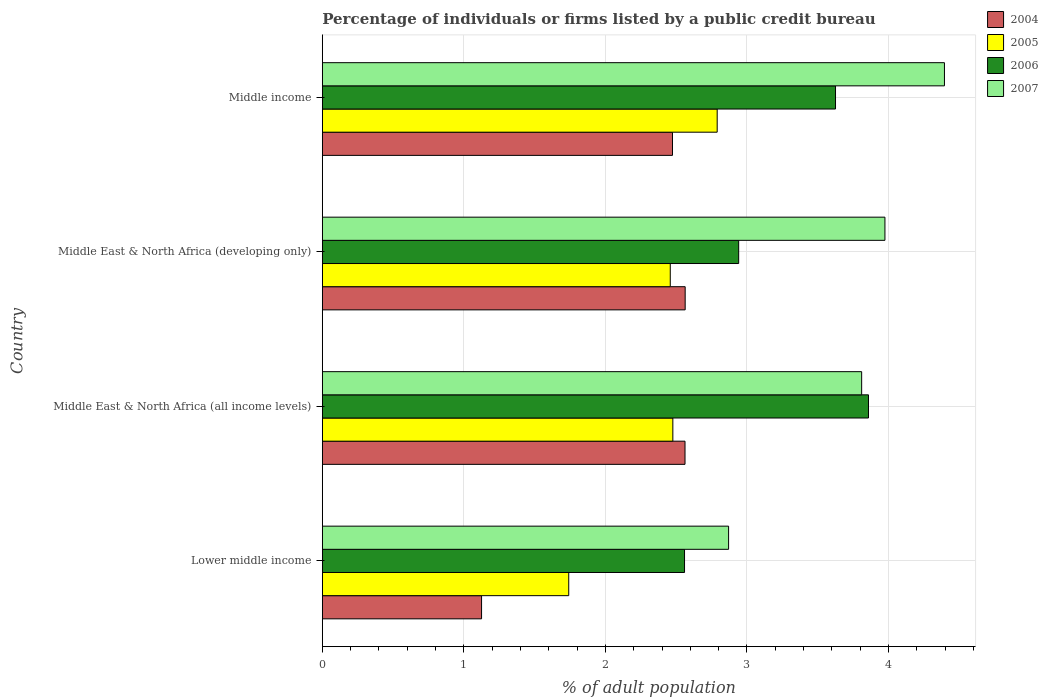How many different coloured bars are there?
Your response must be concise. 4. How many groups of bars are there?
Offer a terse response. 4. Are the number of bars per tick equal to the number of legend labels?
Offer a very short reply. Yes. How many bars are there on the 1st tick from the bottom?
Make the answer very short. 4. What is the label of the 1st group of bars from the top?
Provide a succinct answer. Middle income. What is the percentage of population listed by a public credit bureau in 2007 in Middle East & North Africa (developing only)?
Give a very brief answer. 3.98. Across all countries, what is the maximum percentage of population listed by a public credit bureau in 2007?
Offer a very short reply. 4.4. Across all countries, what is the minimum percentage of population listed by a public credit bureau in 2007?
Your response must be concise. 2.87. In which country was the percentage of population listed by a public credit bureau in 2006 maximum?
Your answer should be very brief. Middle East & North Africa (all income levels). In which country was the percentage of population listed by a public credit bureau in 2007 minimum?
Offer a very short reply. Lower middle income. What is the total percentage of population listed by a public credit bureau in 2007 in the graph?
Provide a succinct answer. 15.05. What is the difference between the percentage of population listed by a public credit bureau in 2006 in Lower middle income and that in Middle East & North Africa (developing only)?
Provide a succinct answer. -0.38. What is the difference between the percentage of population listed by a public credit bureau in 2005 in Middle East & North Africa (all income levels) and the percentage of population listed by a public credit bureau in 2006 in Middle East & North Africa (developing only)?
Provide a short and direct response. -0.47. What is the average percentage of population listed by a public credit bureau in 2006 per country?
Ensure brevity in your answer.  3.25. What is the difference between the percentage of population listed by a public credit bureau in 2007 and percentage of population listed by a public credit bureau in 2005 in Middle income?
Your response must be concise. 1.61. In how many countries, is the percentage of population listed by a public credit bureau in 2007 greater than 3.2 %?
Make the answer very short. 3. What is the ratio of the percentage of population listed by a public credit bureau in 2005 in Middle East & North Africa (all income levels) to that in Middle East & North Africa (developing only)?
Provide a short and direct response. 1.01. Is the percentage of population listed by a public credit bureau in 2006 in Middle East & North Africa (developing only) less than that in Middle income?
Ensure brevity in your answer.  Yes. What is the difference between the highest and the second highest percentage of population listed by a public credit bureau in 2004?
Provide a succinct answer. 0. What is the difference between the highest and the lowest percentage of population listed by a public credit bureau in 2007?
Provide a short and direct response. 1.53. Is the sum of the percentage of population listed by a public credit bureau in 2007 in Lower middle income and Middle East & North Africa (developing only) greater than the maximum percentage of population listed by a public credit bureau in 2005 across all countries?
Provide a succinct answer. Yes. Is it the case that in every country, the sum of the percentage of population listed by a public credit bureau in 2007 and percentage of population listed by a public credit bureau in 2004 is greater than the sum of percentage of population listed by a public credit bureau in 2006 and percentage of population listed by a public credit bureau in 2005?
Your response must be concise. No. How many bars are there?
Your answer should be compact. 16. Are all the bars in the graph horizontal?
Make the answer very short. Yes. How many countries are there in the graph?
Offer a terse response. 4. What is the difference between two consecutive major ticks on the X-axis?
Keep it short and to the point. 1. Are the values on the major ticks of X-axis written in scientific E-notation?
Ensure brevity in your answer.  No. Does the graph contain any zero values?
Your answer should be compact. No. Where does the legend appear in the graph?
Your answer should be very brief. Top right. How are the legend labels stacked?
Offer a terse response. Vertical. What is the title of the graph?
Keep it short and to the point. Percentage of individuals or firms listed by a public credit bureau. What is the label or title of the X-axis?
Your response must be concise. % of adult population. What is the label or title of the Y-axis?
Provide a succinct answer. Country. What is the % of adult population of 2005 in Lower middle income?
Keep it short and to the point. 1.74. What is the % of adult population of 2006 in Lower middle income?
Ensure brevity in your answer.  2.56. What is the % of adult population of 2007 in Lower middle income?
Your answer should be compact. 2.87. What is the % of adult population of 2004 in Middle East & North Africa (all income levels)?
Provide a succinct answer. 2.56. What is the % of adult population in 2005 in Middle East & North Africa (all income levels)?
Offer a very short reply. 2.48. What is the % of adult population in 2006 in Middle East & North Africa (all income levels)?
Your answer should be compact. 3.86. What is the % of adult population of 2007 in Middle East & North Africa (all income levels)?
Your answer should be very brief. 3.81. What is the % of adult population of 2004 in Middle East & North Africa (developing only)?
Your answer should be very brief. 2.56. What is the % of adult population in 2005 in Middle East & North Africa (developing only)?
Your answer should be very brief. 2.46. What is the % of adult population of 2006 in Middle East & North Africa (developing only)?
Provide a short and direct response. 2.94. What is the % of adult population of 2007 in Middle East & North Africa (developing only)?
Offer a terse response. 3.98. What is the % of adult population of 2004 in Middle income?
Provide a succinct answer. 2.47. What is the % of adult population in 2005 in Middle income?
Offer a very short reply. 2.79. What is the % of adult population of 2006 in Middle income?
Provide a succinct answer. 3.63. What is the % of adult population of 2007 in Middle income?
Ensure brevity in your answer.  4.4. Across all countries, what is the maximum % of adult population of 2004?
Your answer should be compact. 2.56. Across all countries, what is the maximum % of adult population in 2005?
Ensure brevity in your answer.  2.79. Across all countries, what is the maximum % of adult population of 2006?
Your answer should be compact. 3.86. Across all countries, what is the maximum % of adult population of 2007?
Provide a short and direct response. 4.4. Across all countries, what is the minimum % of adult population of 2005?
Offer a terse response. 1.74. Across all countries, what is the minimum % of adult population in 2006?
Offer a very short reply. 2.56. Across all countries, what is the minimum % of adult population in 2007?
Offer a very short reply. 2.87. What is the total % of adult population in 2004 in the graph?
Ensure brevity in your answer.  8.73. What is the total % of adult population in 2005 in the graph?
Your answer should be compact. 9.47. What is the total % of adult population in 2006 in the graph?
Your answer should be compact. 12.99. What is the total % of adult population of 2007 in the graph?
Your response must be concise. 15.05. What is the difference between the % of adult population in 2004 in Lower middle income and that in Middle East & North Africa (all income levels)?
Your response must be concise. -1.44. What is the difference between the % of adult population of 2005 in Lower middle income and that in Middle East & North Africa (all income levels)?
Ensure brevity in your answer.  -0.74. What is the difference between the % of adult population of 2006 in Lower middle income and that in Middle East & North Africa (all income levels)?
Provide a succinct answer. -1.3. What is the difference between the % of adult population of 2007 in Lower middle income and that in Middle East & North Africa (all income levels)?
Give a very brief answer. -0.94. What is the difference between the % of adult population of 2004 in Lower middle income and that in Middle East & North Africa (developing only)?
Your answer should be very brief. -1.44. What is the difference between the % of adult population of 2005 in Lower middle income and that in Middle East & North Africa (developing only)?
Give a very brief answer. -0.72. What is the difference between the % of adult population of 2006 in Lower middle income and that in Middle East & North Africa (developing only)?
Keep it short and to the point. -0.38. What is the difference between the % of adult population in 2007 in Lower middle income and that in Middle East & North Africa (developing only)?
Give a very brief answer. -1.1. What is the difference between the % of adult population in 2004 in Lower middle income and that in Middle income?
Provide a succinct answer. -1.35. What is the difference between the % of adult population in 2005 in Lower middle income and that in Middle income?
Your answer should be very brief. -1.05. What is the difference between the % of adult population in 2006 in Lower middle income and that in Middle income?
Offer a terse response. -1.07. What is the difference between the % of adult population in 2007 in Lower middle income and that in Middle income?
Provide a short and direct response. -1.53. What is the difference between the % of adult population in 2004 in Middle East & North Africa (all income levels) and that in Middle East & North Africa (developing only)?
Ensure brevity in your answer.  -0. What is the difference between the % of adult population of 2005 in Middle East & North Africa (all income levels) and that in Middle East & North Africa (developing only)?
Your response must be concise. 0.02. What is the difference between the % of adult population of 2006 in Middle East & North Africa (all income levels) and that in Middle East & North Africa (developing only)?
Make the answer very short. 0.92. What is the difference between the % of adult population in 2007 in Middle East & North Africa (all income levels) and that in Middle East & North Africa (developing only)?
Offer a very short reply. -0.16. What is the difference between the % of adult population of 2004 in Middle East & North Africa (all income levels) and that in Middle income?
Your answer should be very brief. 0.09. What is the difference between the % of adult population in 2005 in Middle East & North Africa (all income levels) and that in Middle income?
Your answer should be very brief. -0.31. What is the difference between the % of adult population in 2006 in Middle East & North Africa (all income levels) and that in Middle income?
Keep it short and to the point. 0.23. What is the difference between the % of adult population in 2007 in Middle East & North Africa (all income levels) and that in Middle income?
Provide a short and direct response. -0.58. What is the difference between the % of adult population of 2004 in Middle East & North Africa (developing only) and that in Middle income?
Offer a terse response. 0.09. What is the difference between the % of adult population in 2005 in Middle East & North Africa (developing only) and that in Middle income?
Offer a terse response. -0.33. What is the difference between the % of adult population of 2006 in Middle East & North Africa (developing only) and that in Middle income?
Your response must be concise. -0.68. What is the difference between the % of adult population in 2007 in Middle East & North Africa (developing only) and that in Middle income?
Provide a short and direct response. -0.42. What is the difference between the % of adult population in 2004 in Lower middle income and the % of adult population in 2005 in Middle East & North Africa (all income levels)?
Provide a short and direct response. -1.35. What is the difference between the % of adult population in 2004 in Lower middle income and the % of adult population in 2006 in Middle East & North Africa (all income levels)?
Your response must be concise. -2.73. What is the difference between the % of adult population of 2004 in Lower middle income and the % of adult population of 2007 in Middle East & North Africa (all income levels)?
Offer a terse response. -2.69. What is the difference between the % of adult population of 2005 in Lower middle income and the % of adult population of 2006 in Middle East & North Africa (all income levels)?
Make the answer very short. -2.12. What is the difference between the % of adult population in 2005 in Lower middle income and the % of adult population in 2007 in Middle East & North Africa (all income levels)?
Ensure brevity in your answer.  -2.07. What is the difference between the % of adult population in 2006 in Lower middle income and the % of adult population in 2007 in Middle East & North Africa (all income levels)?
Keep it short and to the point. -1.25. What is the difference between the % of adult population in 2004 in Lower middle income and the % of adult population in 2005 in Middle East & North Africa (developing only)?
Keep it short and to the point. -1.33. What is the difference between the % of adult population of 2004 in Lower middle income and the % of adult population of 2006 in Middle East & North Africa (developing only)?
Provide a short and direct response. -1.82. What is the difference between the % of adult population of 2004 in Lower middle income and the % of adult population of 2007 in Middle East & North Africa (developing only)?
Give a very brief answer. -2.85. What is the difference between the % of adult population of 2005 in Lower middle income and the % of adult population of 2006 in Middle East & North Africa (developing only)?
Offer a terse response. -1.2. What is the difference between the % of adult population in 2005 in Lower middle income and the % of adult population in 2007 in Middle East & North Africa (developing only)?
Keep it short and to the point. -2.23. What is the difference between the % of adult population of 2006 in Lower middle income and the % of adult population of 2007 in Middle East & North Africa (developing only)?
Offer a very short reply. -1.42. What is the difference between the % of adult population of 2004 in Lower middle income and the % of adult population of 2005 in Middle income?
Make the answer very short. -1.66. What is the difference between the % of adult population in 2004 in Lower middle income and the % of adult population in 2006 in Middle income?
Your answer should be compact. -2.5. What is the difference between the % of adult population in 2004 in Lower middle income and the % of adult population in 2007 in Middle income?
Offer a terse response. -3.27. What is the difference between the % of adult population of 2005 in Lower middle income and the % of adult population of 2006 in Middle income?
Make the answer very short. -1.88. What is the difference between the % of adult population in 2005 in Lower middle income and the % of adult population in 2007 in Middle income?
Provide a succinct answer. -2.65. What is the difference between the % of adult population in 2006 in Lower middle income and the % of adult population in 2007 in Middle income?
Make the answer very short. -1.84. What is the difference between the % of adult population in 2004 in Middle East & North Africa (all income levels) and the % of adult population in 2005 in Middle East & North Africa (developing only)?
Keep it short and to the point. 0.1. What is the difference between the % of adult population in 2004 in Middle East & North Africa (all income levels) and the % of adult population in 2006 in Middle East & North Africa (developing only)?
Provide a succinct answer. -0.38. What is the difference between the % of adult population in 2004 in Middle East & North Africa (all income levels) and the % of adult population in 2007 in Middle East & North Africa (developing only)?
Make the answer very short. -1.41. What is the difference between the % of adult population of 2005 in Middle East & North Africa (all income levels) and the % of adult population of 2006 in Middle East & North Africa (developing only)?
Give a very brief answer. -0.47. What is the difference between the % of adult population in 2005 in Middle East & North Africa (all income levels) and the % of adult population in 2007 in Middle East & North Africa (developing only)?
Your response must be concise. -1.5. What is the difference between the % of adult population in 2006 in Middle East & North Africa (all income levels) and the % of adult population in 2007 in Middle East & North Africa (developing only)?
Provide a short and direct response. -0.12. What is the difference between the % of adult population of 2004 in Middle East & North Africa (all income levels) and the % of adult population of 2005 in Middle income?
Ensure brevity in your answer.  -0.23. What is the difference between the % of adult population in 2004 in Middle East & North Africa (all income levels) and the % of adult population in 2006 in Middle income?
Give a very brief answer. -1.06. What is the difference between the % of adult population in 2004 in Middle East & North Africa (all income levels) and the % of adult population in 2007 in Middle income?
Ensure brevity in your answer.  -1.83. What is the difference between the % of adult population in 2005 in Middle East & North Africa (all income levels) and the % of adult population in 2006 in Middle income?
Give a very brief answer. -1.15. What is the difference between the % of adult population of 2005 in Middle East & North Africa (all income levels) and the % of adult population of 2007 in Middle income?
Ensure brevity in your answer.  -1.92. What is the difference between the % of adult population of 2006 in Middle East & North Africa (all income levels) and the % of adult population of 2007 in Middle income?
Give a very brief answer. -0.54. What is the difference between the % of adult population of 2004 in Middle East & North Africa (developing only) and the % of adult population of 2005 in Middle income?
Make the answer very short. -0.23. What is the difference between the % of adult population of 2004 in Middle East & North Africa (developing only) and the % of adult population of 2006 in Middle income?
Your answer should be very brief. -1.06. What is the difference between the % of adult population of 2004 in Middle East & North Africa (developing only) and the % of adult population of 2007 in Middle income?
Offer a terse response. -1.83. What is the difference between the % of adult population of 2005 in Middle East & North Africa (developing only) and the % of adult population of 2006 in Middle income?
Provide a succinct answer. -1.17. What is the difference between the % of adult population in 2005 in Middle East & North Africa (developing only) and the % of adult population in 2007 in Middle income?
Your answer should be very brief. -1.94. What is the difference between the % of adult population of 2006 in Middle East & North Africa (developing only) and the % of adult population of 2007 in Middle income?
Your response must be concise. -1.45. What is the average % of adult population of 2004 per country?
Provide a short and direct response. 2.18. What is the average % of adult population in 2005 per country?
Your response must be concise. 2.37. What is the average % of adult population of 2006 per country?
Offer a terse response. 3.25. What is the average % of adult population of 2007 per country?
Ensure brevity in your answer.  3.76. What is the difference between the % of adult population of 2004 and % of adult population of 2005 in Lower middle income?
Offer a terse response. -0.62. What is the difference between the % of adult population of 2004 and % of adult population of 2006 in Lower middle income?
Keep it short and to the point. -1.43. What is the difference between the % of adult population in 2004 and % of adult population in 2007 in Lower middle income?
Offer a terse response. -1.75. What is the difference between the % of adult population of 2005 and % of adult population of 2006 in Lower middle income?
Make the answer very short. -0.82. What is the difference between the % of adult population of 2005 and % of adult population of 2007 in Lower middle income?
Keep it short and to the point. -1.13. What is the difference between the % of adult population of 2006 and % of adult population of 2007 in Lower middle income?
Your answer should be compact. -0.31. What is the difference between the % of adult population in 2004 and % of adult population in 2005 in Middle East & North Africa (all income levels)?
Provide a succinct answer. 0.09. What is the difference between the % of adult population in 2004 and % of adult population in 2006 in Middle East & North Africa (all income levels)?
Your answer should be compact. -1.3. What is the difference between the % of adult population in 2004 and % of adult population in 2007 in Middle East & North Africa (all income levels)?
Offer a terse response. -1.25. What is the difference between the % of adult population of 2005 and % of adult population of 2006 in Middle East & North Africa (all income levels)?
Your response must be concise. -1.38. What is the difference between the % of adult population in 2005 and % of adult population in 2007 in Middle East & North Africa (all income levels)?
Offer a very short reply. -1.33. What is the difference between the % of adult population in 2006 and % of adult population in 2007 in Middle East & North Africa (all income levels)?
Give a very brief answer. 0.05. What is the difference between the % of adult population of 2004 and % of adult population of 2005 in Middle East & North Africa (developing only)?
Give a very brief answer. 0.11. What is the difference between the % of adult population in 2004 and % of adult population in 2006 in Middle East & North Africa (developing only)?
Give a very brief answer. -0.38. What is the difference between the % of adult population in 2004 and % of adult population in 2007 in Middle East & North Africa (developing only)?
Your response must be concise. -1.41. What is the difference between the % of adult population of 2005 and % of adult population of 2006 in Middle East & North Africa (developing only)?
Offer a very short reply. -0.48. What is the difference between the % of adult population in 2005 and % of adult population in 2007 in Middle East & North Africa (developing only)?
Offer a terse response. -1.52. What is the difference between the % of adult population of 2006 and % of adult population of 2007 in Middle East & North Africa (developing only)?
Offer a very short reply. -1.03. What is the difference between the % of adult population in 2004 and % of adult population in 2005 in Middle income?
Your answer should be very brief. -0.32. What is the difference between the % of adult population of 2004 and % of adult population of 2006 in Middle income?
Your answer should be very brief. -1.15. What is the difference between the % of adult population of 2004 and % of adult population of 2007 in Middle income?
Provide a succinct answer. -1.92. What is the difference between the % of adult population in 2005 and % of adult population in 2006 in Middle income?
Make the answer very short. -0.84. What is the difference between the % of adult population of 2005 and % of adult population of 2007 in Middle income?
Your answer should be compact. -1.61. What is the difference between the % of adult population of 2006 and % of adult population of 2007 in Middle income?
Keep it short and to the point. -0.77. What is the ratio of the % of adult population in 2004 in Lower middle income to that in Middle East & North Africa (all income levels)?
Keep it short and to the point. 0.44. What is the ratio of the % of adult population of 2005 in Lower middle income to that in Middle East & North Africa (all income levels)?
Make the answer very short. 0.7. What is the ratio of the % of adult population in 2006 in Lower middle income to that in Middle East & North Africa (all income levels)?
Keep it short and to the point. 0.66. What is the ratio of the % of adult population in 2007 in Lower middle income to that in Middle East & North Africa (all income levels)?
Make the answer very short. 0.75. What is the ratio of the % of adult population in 2004 in Lower middle income to that in Middle East & North Africa (developing only)?
Your answer should be very brief. 0.44. What is the ratio of the % of adult population in 2005 in Lower middle income to that in Middle East & North Africa (developing only)?
Provide a succinct answer. 0.71. What is the ratio of the % of adult population in 2006 in Lower middle income to that in Middle East & North Africa (developing only)?
Your answer should be very brief. 0.87. What is the ratio of the % of adult population of 2007 in Lower middle income to that in Middle East & North Africa (developing only)?
Your answer should be very brief. 0.72. What is the ratio of the % of adult population in 2004 in Lower middle income to that in Middle income?
Keep it short and to the point. 0.45. What is the ratio of the % of adult population of 2005 in Lower middle income to that in Middle income?
Provide a succinct answer. 0.62. What is the ratio of the % of adult population in 2006 in Lower middle income to that in Middle income?
Offer a terse response. 0.71. What is the ratio of the % of adult population of 2007 in Lower middle income to that in Middle income?
Give a very brief answer. 0.65. What is the ratio of the % of adult population in 2005 in Middle East & North Africa (all income levels) to that in Middle East & North Africa (developing only)?
Offer a very short reply. 1.01. What is the ratio of the % of adult population of 2006 in Middle East & North Africa (all income levels) to that in Middle East & North Africa (developing only)?
Make the answer very short. 1.31. What is the ratio of the % of adult population in 2007 in Middle East & North Africa (all income levels) to that in Middle East & North Africa (developing only)?
Your answer should be compact. 0.96. What is the ratio of the % of adult population of 2004 in Middle East & North Africa (all income levels) to that in Middle income?
Your response must be concise. 1.04. What is the ratio of the % of adult population in 2005 in Middle East & North Africa (all income levels) to that in Middle income?
Your response must be concise. 0.89. What is the ratio of the % of adult population of 2006 in Middle East & North Africa (all income levels) to that in Middle income?
Ensure brevity in your answer.  1.06. What is the ratio of the % of adult population of 2007 in Middle East & North Africa (all income levels) to that in Middle income?
Keep it short and to the point. 0.87. What is the ratio of the % of adult population in 2004 in Middle East & North Africa (developing only) to that in Middle income?
Provide a short and direct response. 1.04. What is the ratio of the % of adult population in 2005 in Middle East & North Africa (developing only) to that in Middle income?
Your answer should be compact. 0.88. What is the ratio of the % of adult population in 2006 in Middle East & North Africa (developing only) to that in Middle income?
Your response must be concise. 0.81. What is the ratio of the % of adult population of 2007 in Middle East & North Africa (developing only) to that in Middle income?
Your answer should be compact. 0.9. What is the difference between the highest and the second highest % of adult population of 2004?
Give a very brief answer. 0. What is the difference between the highest and the second highest % of adult population in 2005?
Ensure brevity in your answer.  0.31. What is the difference between the highest and the second highest % of adult population of 2006?
Provide a succinct answer. 0.23. What is the difference between the highest and the second highest % of adult population of 2007?
Ensure brevity in your answer.  0.42. What is the difference between the highest and the lowest % of adult population in 2004?
Provide a succinct answer. 1.44. What is the difference between the highest and the lowest % of adult population in 2005?
Offer a terse response. 1.05. What is the difference between the highest and the lowest % of adult population of 2006?
Offer a terse response. 1.3. What is the difference between the highest and the lowest % of adult population of 2007?
Give a very brief answer. 1.53. 